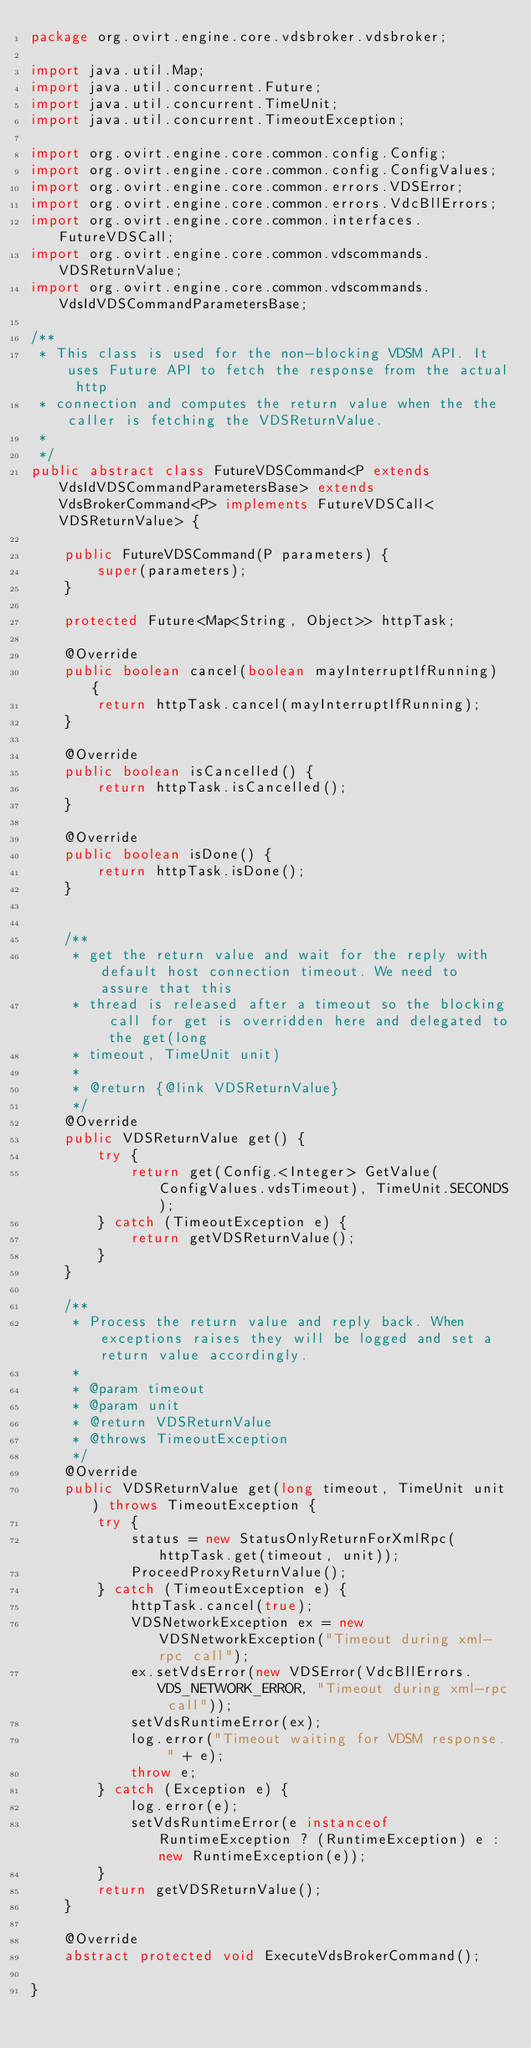Convert code to text. <code><loc_0><loc_0><loc_500><loc_500><_Java_>package org.ovirt.engine.core.vdsbroker.vdsbroker;

import java.util.Map;
import java.util.concurrent.Future;
import java.util.concurrent.TimeUnit;
import java.util.concurrent.TimeoutException;

import org.ovirt.engine.core.common.config.Config;
import org.ovirt.engine.core.common.config.ConfigValues;
import org.ovirt.engine.core.common.errors.VDSError;
import org.ovirt.engine.core.common.errors.VdcBllErrors;
import org.ovirt.engine.core.common.interfaces.FutureVDSCall;
import org.ovirt.engine.core.common.vdscommands.VDSReturnValue;
import org.ovirt.engine.core.common.vdscommands.VdsIdVDSCommandParametersBase;

/**
 * This class is used for the non-blocking VDSM API. It uses Future API to fetch the response from the actual http
 * connection and computes the return value when the the caller is fetching the VDSReturnValue.
 *
 */
public abstract class FutureVDSCommand<P extends VdsIdVDSCommandParametersBase> extends VdsBrokerCommand<P> implements FutureVDSCall<VDSReturnValue> {

    public FutureVDSCommand(P parameters) {
        super(parameters);
    }

    protected Future<Map<String, Object>> httpTask;

    @Override
    public boolean cancel(boolean mayInterruptIfRunning) {
        return httpTask.cancel(mayInterruptIfRunning);
    }

    @Override
    public boolean isCancelled() {
        return httpTask.isCancelled();
    }

    @Override
    public boolean isDone() {
        return httpTask.isDone();
    }


    /**
     * get the return value and wait for the reply with default host connection timeout. We need to assure that this
     * thread is released after a timeout so the blocking call for get is overridden here and delegated to the get(long
     * timeout, TimeUnit unit)
     *
     * @return {@link VDSReturnValue}
     */
    @Override
    public VDSReturnValue get() {
        try {
            return get(Config.<Integer> GetValue(ConfigValues.vdsTimeout), TimeUnit.SECONDS);
        } catch (TimeoutException e) {
            return getVDSReturnValue();
        }
    }

    /**
     * Process the return value and reply back. When exceptions raises they will be logged and set a return value accordingly.
     *
     * @param timeout
     * @param unit
     * @return VDSReturnValue
     * @throws TimeoutException
     */
    @Override
    public VDSReturnValue get(long timeout, TimeUnit unit) throws TimeoutException {
        try {
            status = new StatusOnlyReturnForXmlRpc(httpTask.get(timeout, unit));
            ProceedProxyReturnValue();
        } catch (TimeoutException e) {
            httpTask.cancel(true);
            VDSNetworkException ex = new VDSNetworkException("Timeout during xml-rpc call");
            ex.setVdsError(new VDSError(VdcBllErrors.VDS_NETWORK_ERROR, "Timeout during xml-rpc call"));
            setVdsRuntimeError(ex);
            log.error("Timeout waiting for VDSM response. " + e);
            throw e;
        } catch (Exception e) {
            log.error(e);
            setVdsRuntimeError(e instanceof RuntimeException ? (RuntimeException) e : new RuntimeException(e));
        }
        return getVDSReturnValue();
    }

    @Override
    abstract protected void ExecuteVdsBrokerCommand();

}
</code> 